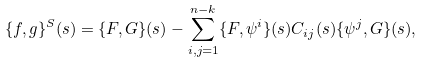Convert formula to latex. <formula><loc_0><loc_0><loc_500><loc_500>\{ f , g \} ^ { S } ( s ) = \{ F , G \} ( s ) - \sum _ { i , j = 1 } ^ { n - k } \{ F , \psi ^ { i } \} ( s ) C _ { i j } ( s ) \{ \psi ^ { j } , G \} ( s ) ,</formula> 